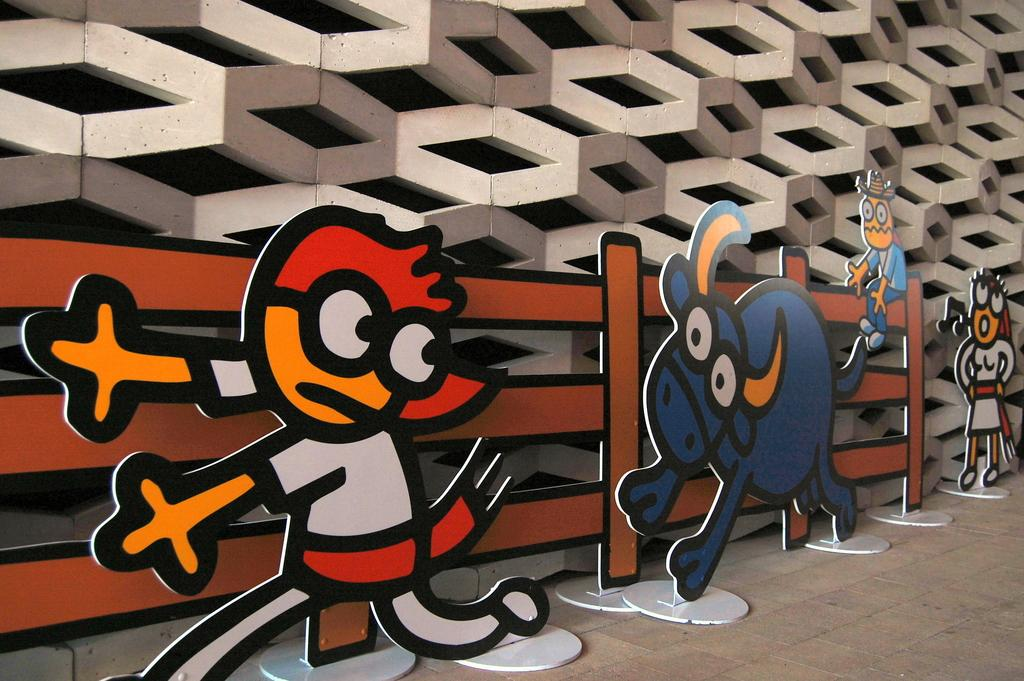What type of objects can be seen in the image? There are boards present in the image. What is visible in the background of the image? There is a wall in the background of the image. What is at the bottom of the image? There is a floor at the bottom of the image. How many books are stacked on the boards in the image? There are no books present in the image; only boards can be seen. 